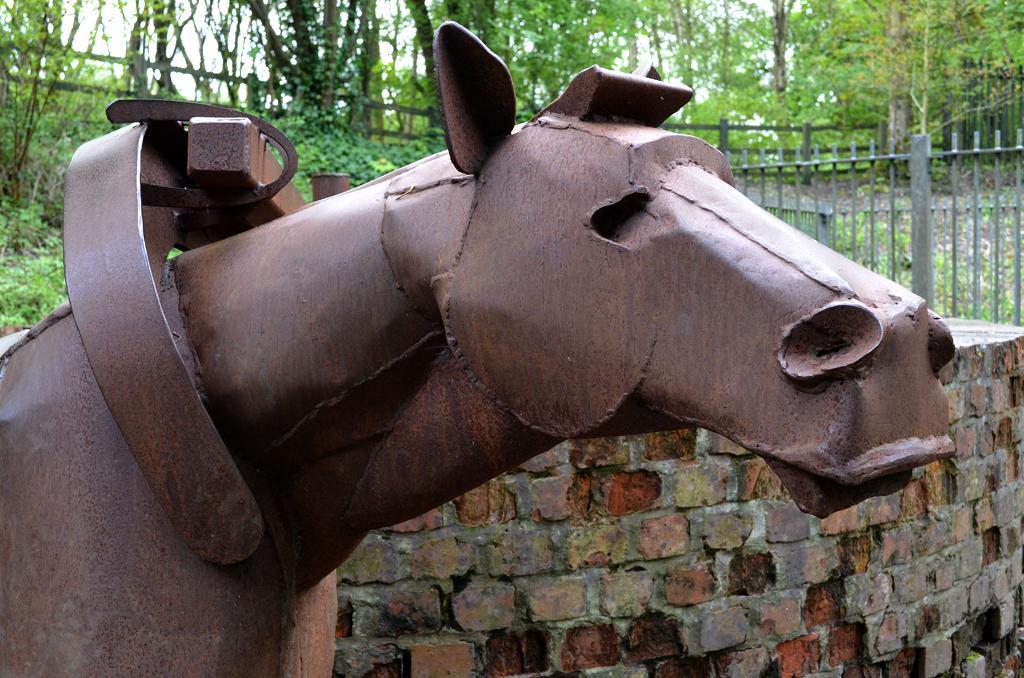In one or two sentences, can you explain what this image depicts? In the foreground I can see a metal horse and bricks wall. In the background I can see a fence, plants, trees and the sky. This image is taken may be near the park. 